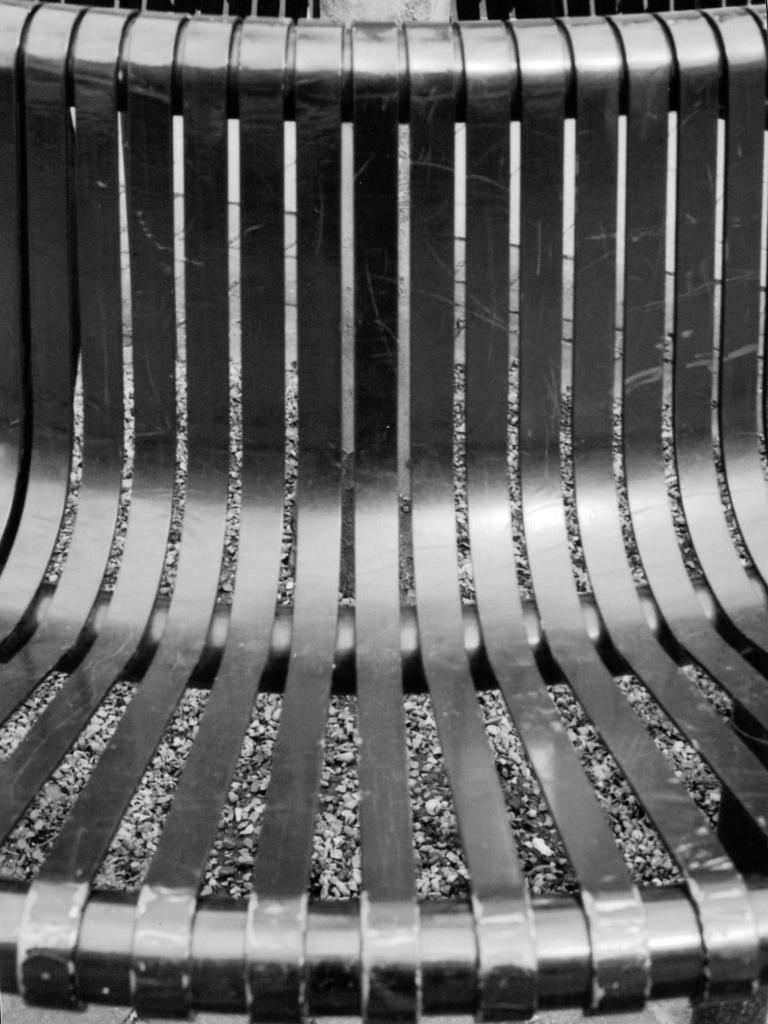Can you describe this image briefly? In this image, we can see a metal chair. We can see some stones and some objects at the top. 